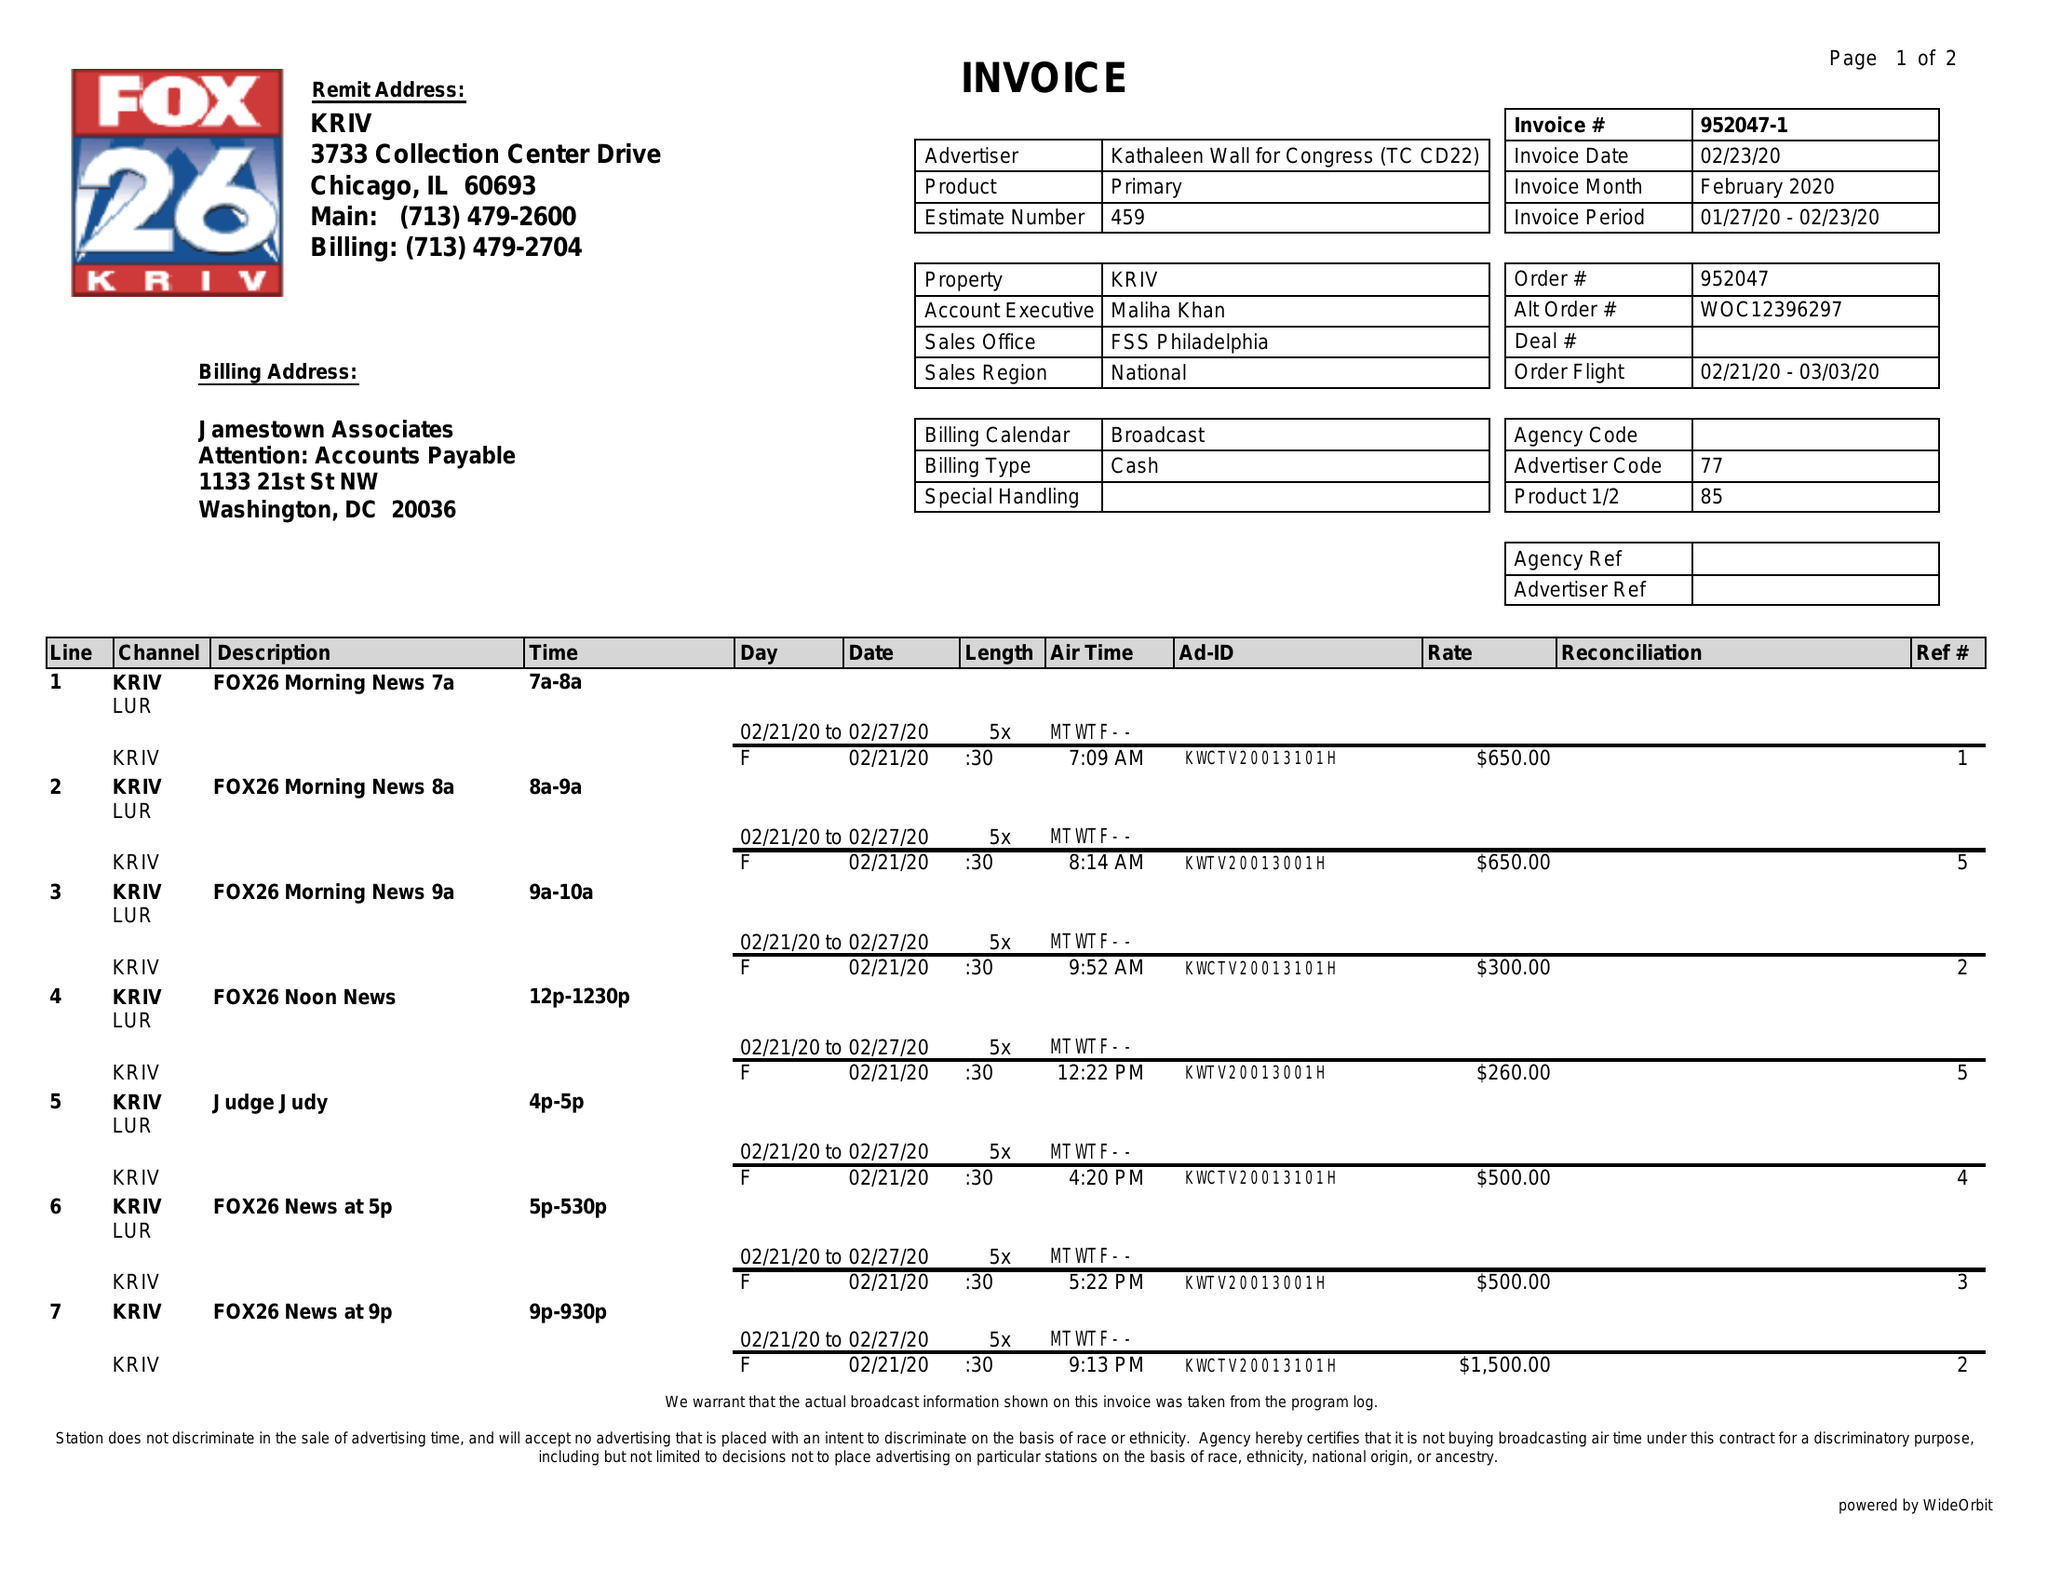What is the value for the flight_to?
Answer the question using a single word or phrase. 03/03/20 